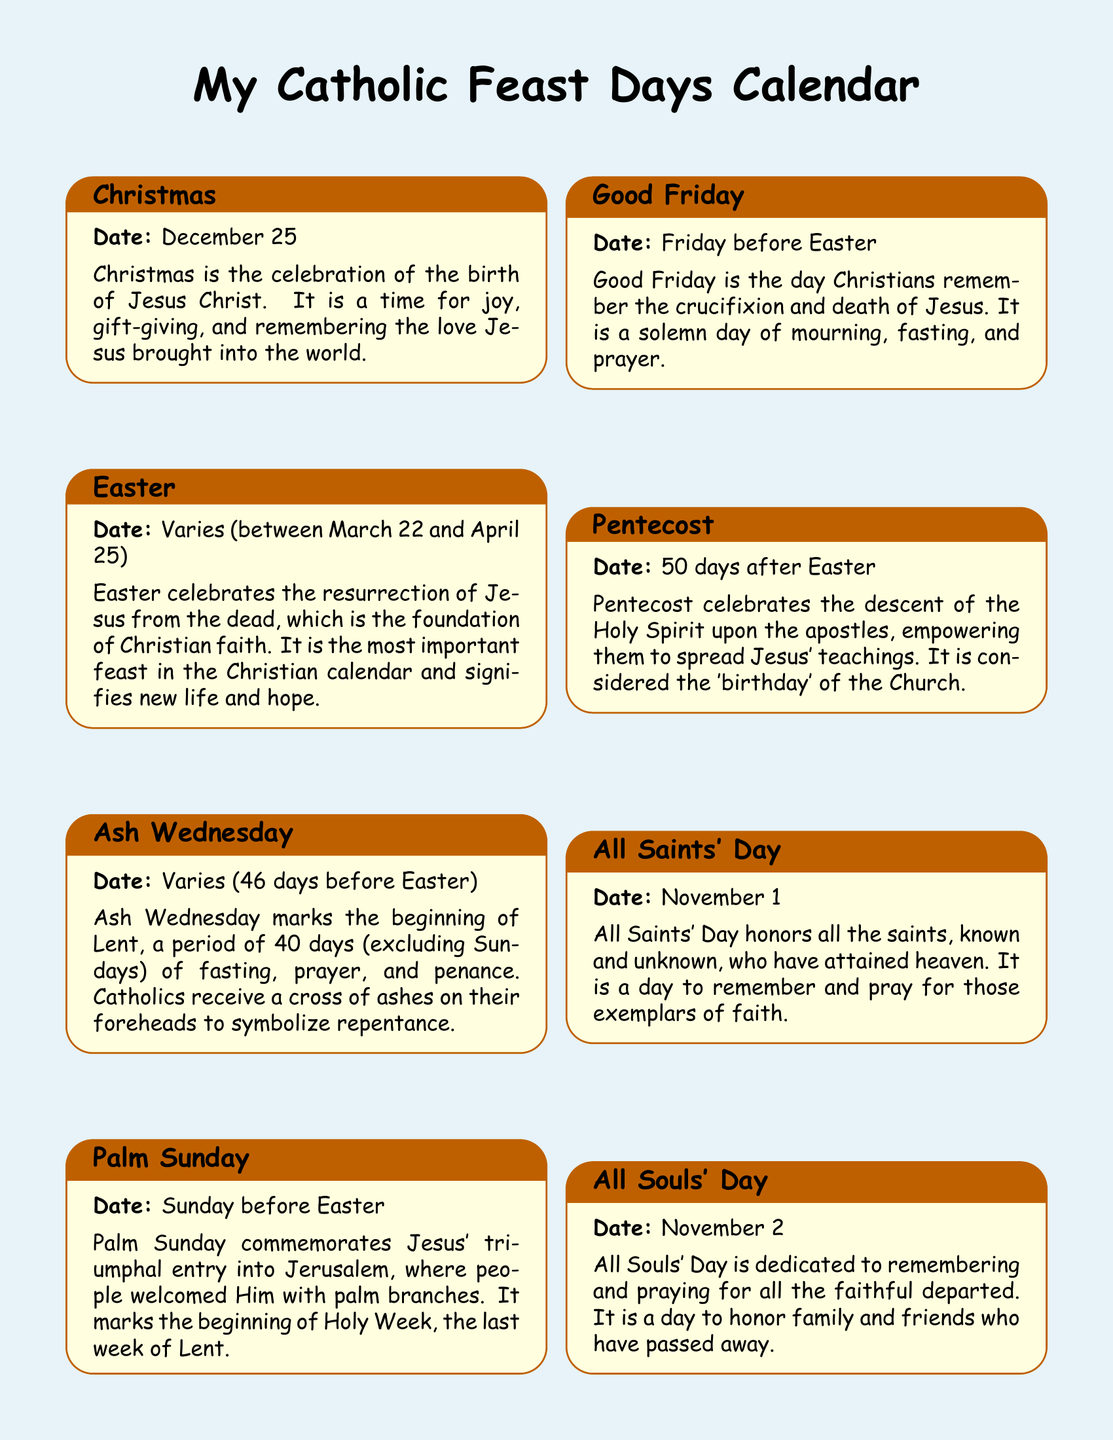What is the date of Christmas? Christmas is celebrated on December 25, as stated in the document.
Answer: December 25 What feast commemorates Jesus' entry into Jerusalem? Palm Sunday commemorates Jesus' triumphal entry into Jerusalem according to the document.
Answer: Palm Sunday Which feast is known as the 'birthday' of the Church? The document states that Pentecost is considered the 'birthday' of the Church.
Answer: Pentecost What is the significance of Ash Wednesday? Ash Wednesday marks the beginning of Lent, as described in the document.
Answer: Beginning of Lent When is All Saints' Day celebrated? All Saints' Day is celebrated on November 1 according to the document.
Answer: November 1 What does the Feast of the Immaculate Conception honor? The feast honors the belief that Mary was conceived without original sin, as mentioned in the document.
Answer: Mary's conception without original sin What event does Good Friday remember? Good Friday remembers the crucifixion and death of Jesus according to the document.
Answer: Crucifixion and death of Jesus How many days after Easter is Pentecost? Pentecost is celebrated 50 days after Easter as per the document’s information.
Answer: 50 days What is celebrated on August 15? The document states that The Assumption of the Blessed Virgin Mary is celebrated on August 15.
Answer: The Assumption of the Blessed Virgin Mary 